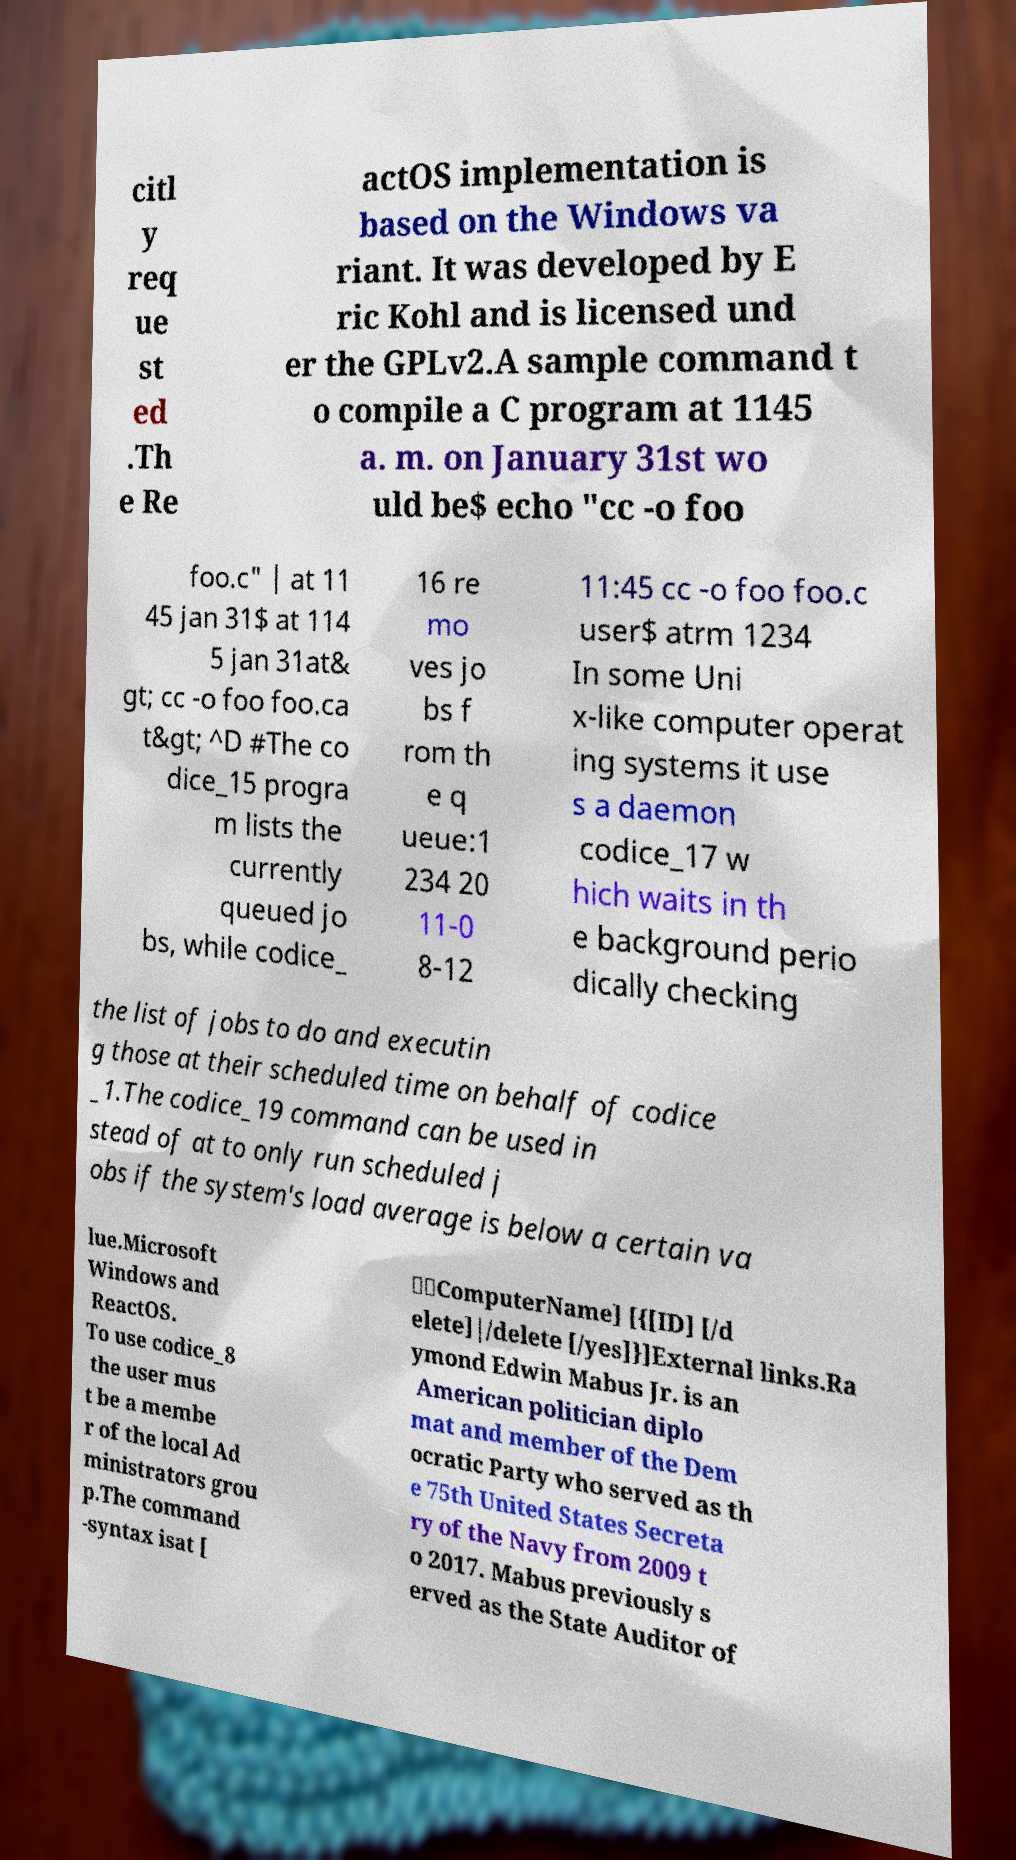Can you accurately transcribe the text from the provided image for me? citl y req ue st ed .Th e Re actOS implementation is based on the Windows va riant. It was developed by E ric Kohl and is licensed und er the GPLv2.A sample command t o compile a C program at 1145 a. m. on January 31st wo uld be$ echo "cc -o foo foo.c" | at 11 45 jan 31$ at 114 5 jan 31at& gt; cc -o foo foo.ca t&gt; ^D #The co dice_15 progra m lists the currently queued jo bs, while codice_ 16 re mo ves jo bs f rom th e q ueue:1 234 20 11-0 8-12 11:45 cc -o foo foo.c user$ atrm 1234 In some Uni x-like computer operat ing systems it use s a daemon codice_17 w hich waits in th e background perio dically checking the list of jobs to do and executin g those at their scheduled time on behalf of codice _1.The codice_19 command can be used in stead of at to only run scheduled j obs if the system's load average is below a certain va lue.Microsoft Windows and ReactOS. To use codice_8 the user mus t be a membe r of the local Ad ministrators grou p.The command -syntax isat [ \\ComputerName] [{[ID] [/d elete]|/delete [/yes]}]External links.Ra ymond Edwin Mabus Jr. is an American politician diplo mat and member of the Dem ocratic Party who served as th e 75th United States Secreta ry of the Navy from 2009 t o 2017. Mabus previously s erved as the State Auditor of 